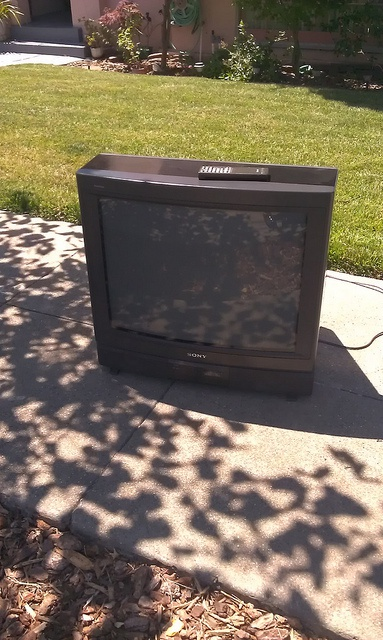Describe the objects in this image and their specific colors. I can see tv in olive, black, and gray tones, remote in olive, black, gray, and darkgray tones, potted plant in olive, gray, black, and maroon tones, and potted plant in maroon, gray, olive, black, and tan tones in this image. 